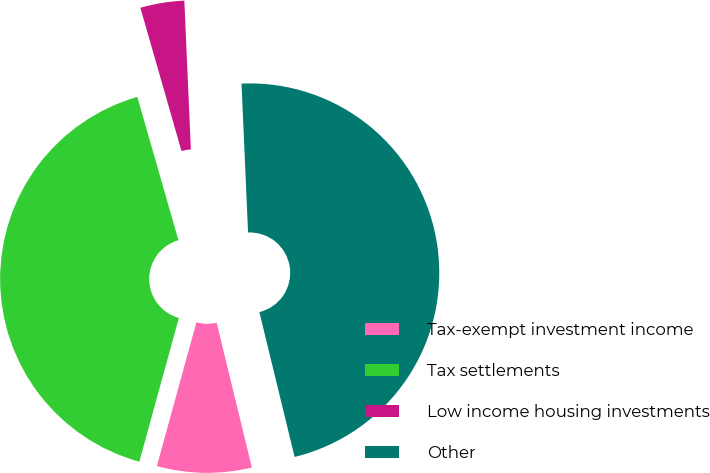Convert chart. <chart><loc_0><loc_0><loc_500><loc_500><pie_chart><fcel>Tax-exempt investment income<fcel>Tax settlements<fcel>Low income housing investments<fcel>Other<nl><fcel>8.07%<fcel>41.28%<fcel>3.75%<fcel>46.9%<nl></chart> 